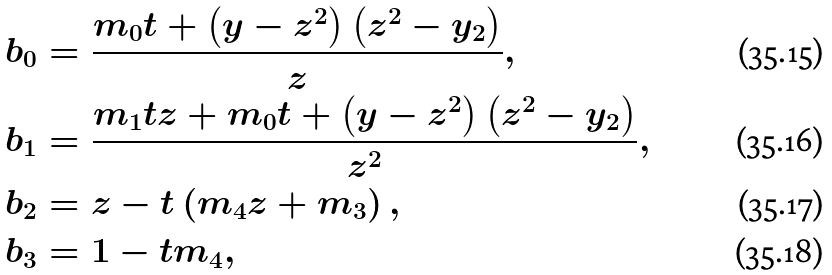Convert formula to latex. <formula><loc_0><loc_0><loc_500><loc_500>b _ { 0 } & = \frac { m _ { 0 } t + \left ( y - z ^ { 2 } \right ) \left ( z ^ { 2 } - y _ { 2 } \right ) } { z } , \\ b _ { 1 } & = \frac { m _ { 1 } t z + m _ { 0 } t + \left ( y - z ^ { 2 } \right ) \left ( z ^ { 2 } - y _ { 2 } \right ) } { z ^ { 2 } } , \\ b _ { 2 } & = z - t \left ( m _ { 4 } z + m _ { 3 } \right ) , \\ b _ { 3 } & = 1 - t m _ { 4 } ,</formula> 